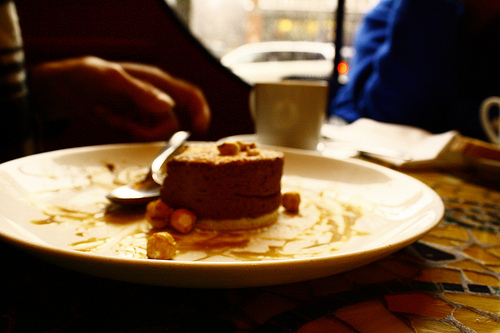<image>
Is there a spoon behind the cup? No. The spoon is not behind the cup. From this viewpoint, the spoon appears to be positioned elsewhere in the scene. 